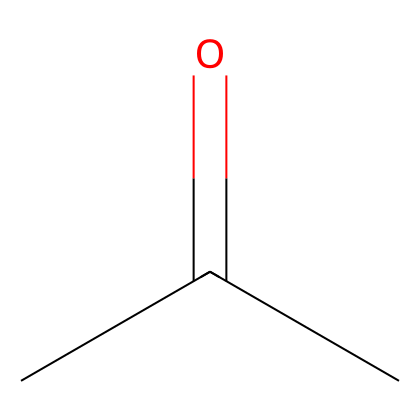What is the molecular formula of the compound represented? By analyzing the SMILES representation CC(=O)C, we can deduce the molecular formula. The 'C's represent carbon atoms, and there are three carbons. The 'O' represents one oxygen atom. Together, this gives the molecular formula C3H6O.
Answer: C3H6O How many carbon atoms are present in the structure? In the SMILES representation CC(=O)C, there are three 'C' characters, indicating there are three carbon atoms in total.
Answer: 3 What type of functional group is present in this molecule? The '=' sign in the SMILES indicates a double bond to the oxygen atom. This signifies that the functional group present is a carbonyl group, which is associated with ketones and aldehydes. In this case, since the carbonyl carbon is bonded to two other carbon atoms, it indicates a ketone functional group.
Answer: ketone What is the hybridization of the carbonyl carbon in this molecule? The carbonyl carbon is part of a carbonyl group (C=O), which involves a double bond with oxygen. The structure around this carbon is trigonal planar due to the carbon's three substituents. This configuration implies that the carbon is sp2 hybridized.
Answer: sp2 Determine the molecular weight of acetone based on its formula. To find the molecular weight of C3H6O, we sum the atomic weights of its constituent atoms: (3 × 12.01 for carbon) + (6 × 1.008 for hydrogen) + (1 × 16.00 for oxygen), resulting in a molecular weight of approximately 58.08 g/mol.
Answer: 58.08 g/mol 